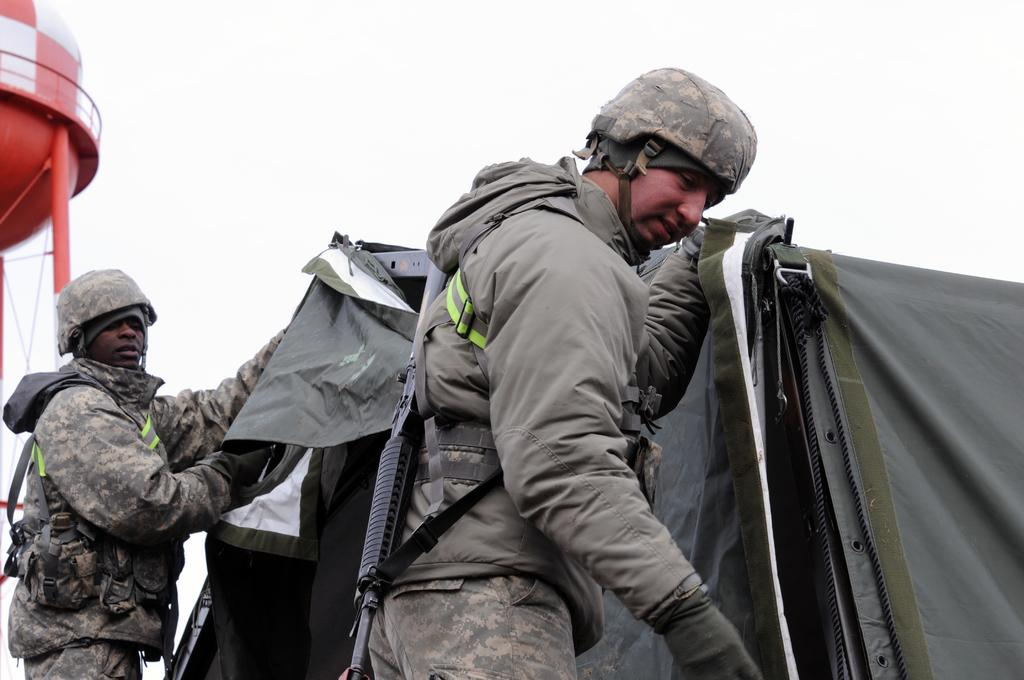How many people are in the image? There are two persons standing in the image. What is the person in front wearing? The person in front is wearing a brown jacket. What can be seen in the background of the image? There is a tent in the background of the image. What color is the tent? The tent is brown in color. What is visible in the image besides the people and the tent? The sky is visible in the image. What color is the sky depicted as? The sky is depicted as white in color. How many snakes are crawling on the person wearing the brown jacket in the image? There are no snakes visible in the image; the person is wearing a brown jacket and standing with another person. What type of glue is being used to hold the tent together in the image? There is no glue present in the image; the tent is simply depicted as a brown structure in the background. 